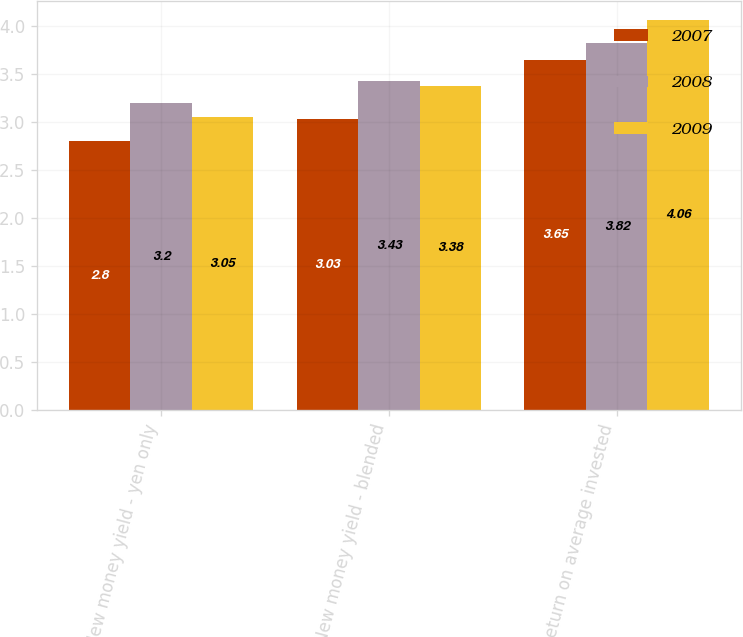<chart> <loc_0><loc_0><loc_500><loc_500><stacked_bar_chart><ecel><fcel>New money yield - yen only<fcel>New money yield - blended<fcel>Return on average invested<nl><fcel>2007<fcel>2.8<fcel>3.03<fcel>3.65<nl><fcel>2008<fcel>3.2<fcel>3.43<fcel>3.82<nl><fcel>2009<fcel>3.05<fcel>3.38<fcel>4.06<nl></chart> 